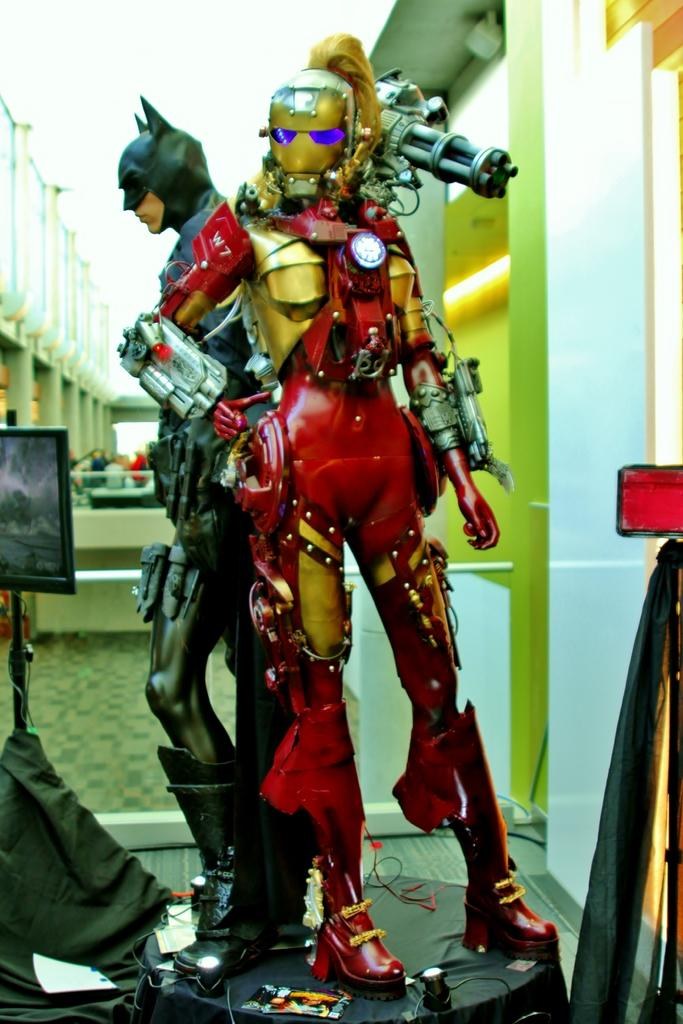How many dolls are present in the image? There are 2 dolls in the image. What are the shapes of the dolls? One doll is in the shape of an iron man, and the other is in the shape of a bat man. What can be seen on the left side of the image? There is an electronic display on the left side of the image. What type of bread can be seen in the image? There is no bread present in the image. How many snails are visible in the image? There are no snails visible in the image. 